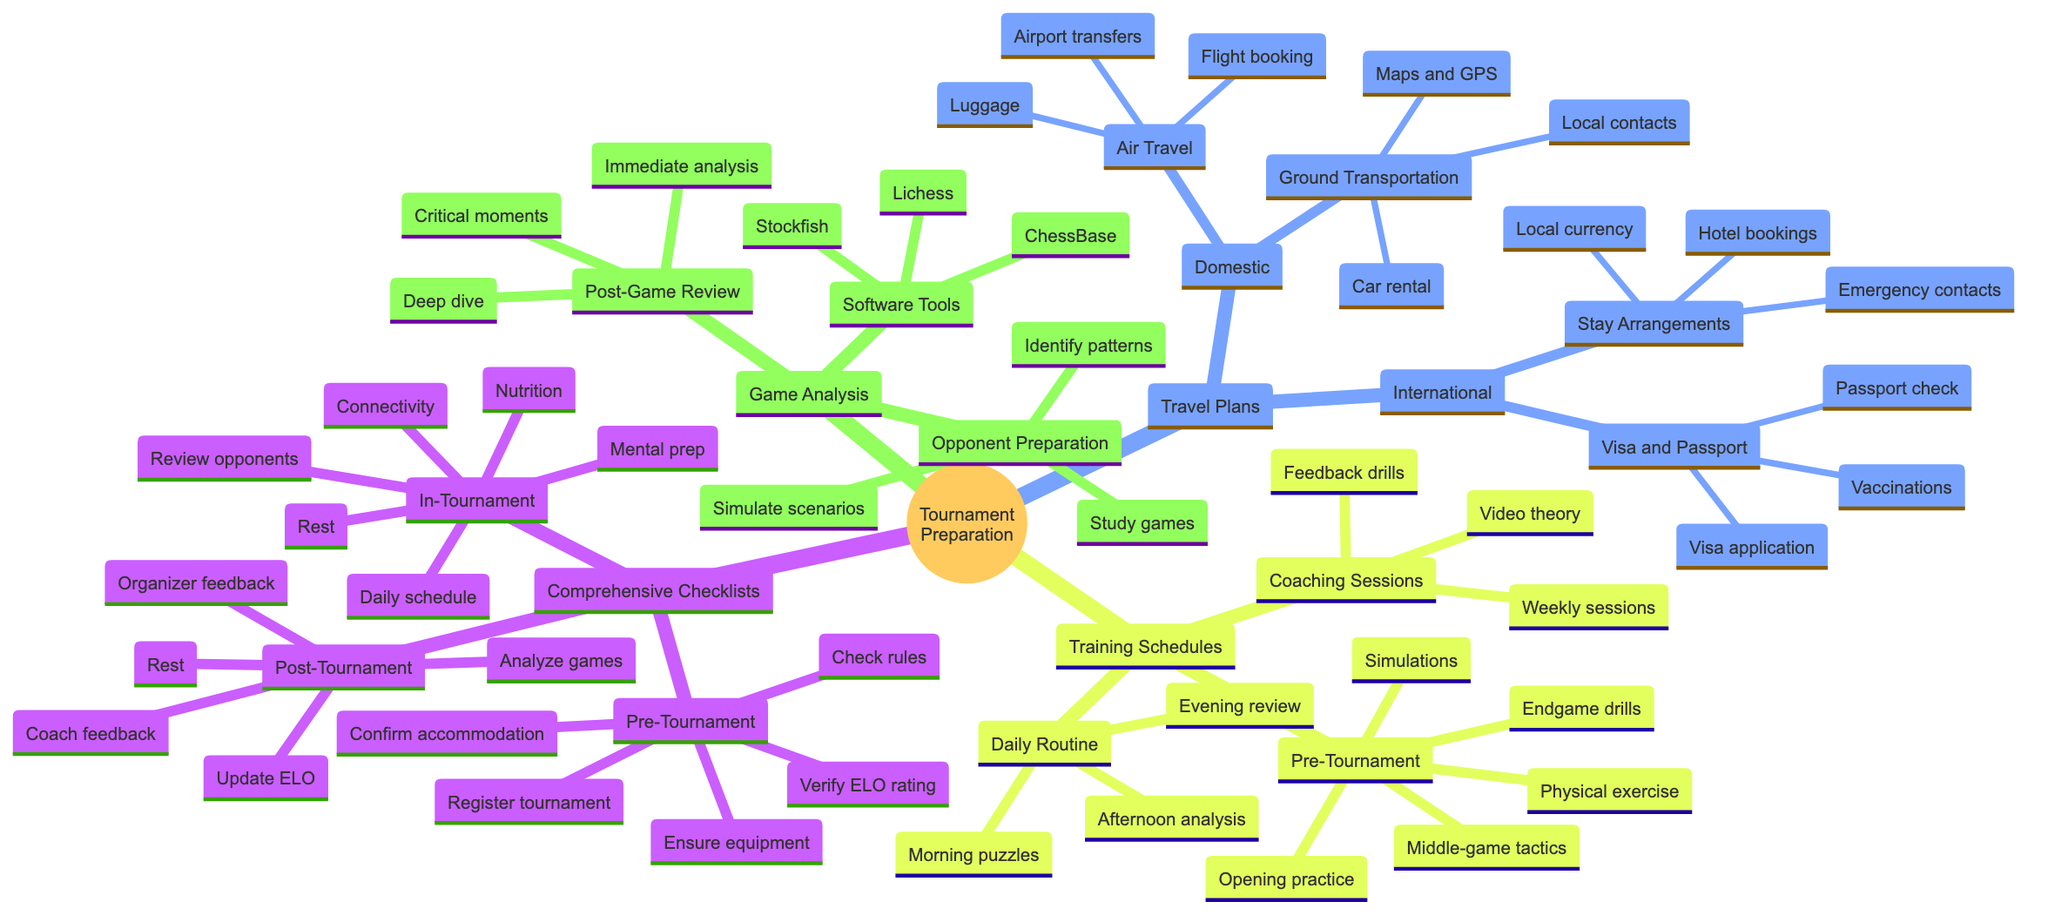What are the three sections under Comprehensive Checklists? The mind map lists three subsections under Comprehensive Checklists: Pre-Tournament, In-Tournament, and Post-Tournament, which can be found directly branching out from the Comprehensive Checklists node.
Answer: Pre-Tournament, In-Tournament, Post-Tournament How many items are in the Post-Tournament section? Counting the items listed under Post-Tournament, there are five distinct items: Analyze game performances, Update personal ELO tracker, Share experiences and learnings with a coach, Plan time for rest and recovery, and Provide feedback to organizers if needed.
Answer: 5 What is one requirement under Visa and Passport for International travel? The diagram clearly shows that one of the requirements listed under the Visa and Passport subsection is "Visa application and documentation," which is essential for international travel preparations.
Answer: Visa application and documentation Which training activity is included in the Pre-Tournament Training section? From the Pre-Tournament Training section of the mind map, one activity listed is "Opening repertoire practice," indicating it is a focused training activity leading up to the tournament.
Answer: Opening repertoire practice What is the main focus of the Daily Routine section in Training Schedules? The Daily Routine section emphasizes specific activities scheduled for each part of the day: Morning, Afternoon, and Evening, indicating it allocates time for Tactical puzzles and rapid games, analyzing classic games, and reviewing own games and mistakes, respectively.
Answer: Morning puzzles, Afternoon analysis, Evening review What software tools are listed for Game Analysis? The mind map mentions three software tools specifically for Game Analysis: Stockfish, ChessBase, and Lichess analysis board, all categorized under the Software Tools section.
Answer: Stockfish, ChessBase, Lichess analysis board What are two elements included in Domestic travel plans under Ground Transportation? In the Ground Transportation subsection of Domestic travel plans, two elements listed provide details about arrangements including "Car rental or public transport arrangements" and "Maps and GPS readiness," showcasing logistical considerations.
Answer: Car rental, Maps and GPS What should be reviewed daily during the In-Tournament phase? During the In-Tournament phase, one of the items to be reviewed daily is the "Daily schedule review," which indicates an ongoing need to stay informed about the day’s activities.
Answer: Daily schedule review How does Post-Game Review suggest handling critical moments? The Post-Game Review section emphasizes identifying "Critical moments and blunders," guiding players to focus on key areas of their game for improvement through subsequent analysis.
Answer: Critical moments and blunders 